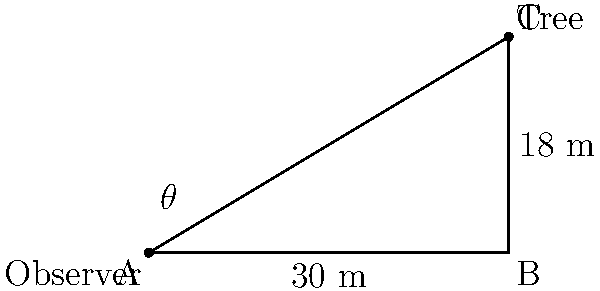During a nature hike, you stop to observe a tall tree. Standing 30 meters away from the base of the tree, you use a clinometer to measure the angle of elevation to the treetop, which is 18 meters high. What is the angle of elevation ($\theta$) to the nearest degree? To solve this problem, we'll use trigonometry:

1) First, let's identify the parts of the right triangle:
   - The adjacent side is the distance from the observer to the tree base (30 m)
   - The opposite side is the height of the tree (18 m)
   - The angle we're looking for is $\theta$

2) We can use the tangent function to find the angle:
   
   $\tan(\theta) = \frac{\text{opposite}}{\text{adjacent}} = \frac{18}{30} = 0.6$

3) To find $\theta$, we need to use the inverse tangent (arctan or $\tan^{-1}$):

   $\theta = \tan^{-1}(0.6)$

4) Using a calculator or trigonometric tables:

   $\theta \approx 30.96^\circ$

5) Rounding to the nearest degree:

   $\theta \approx 31^\circ$
Answer: $31^\circ$ 